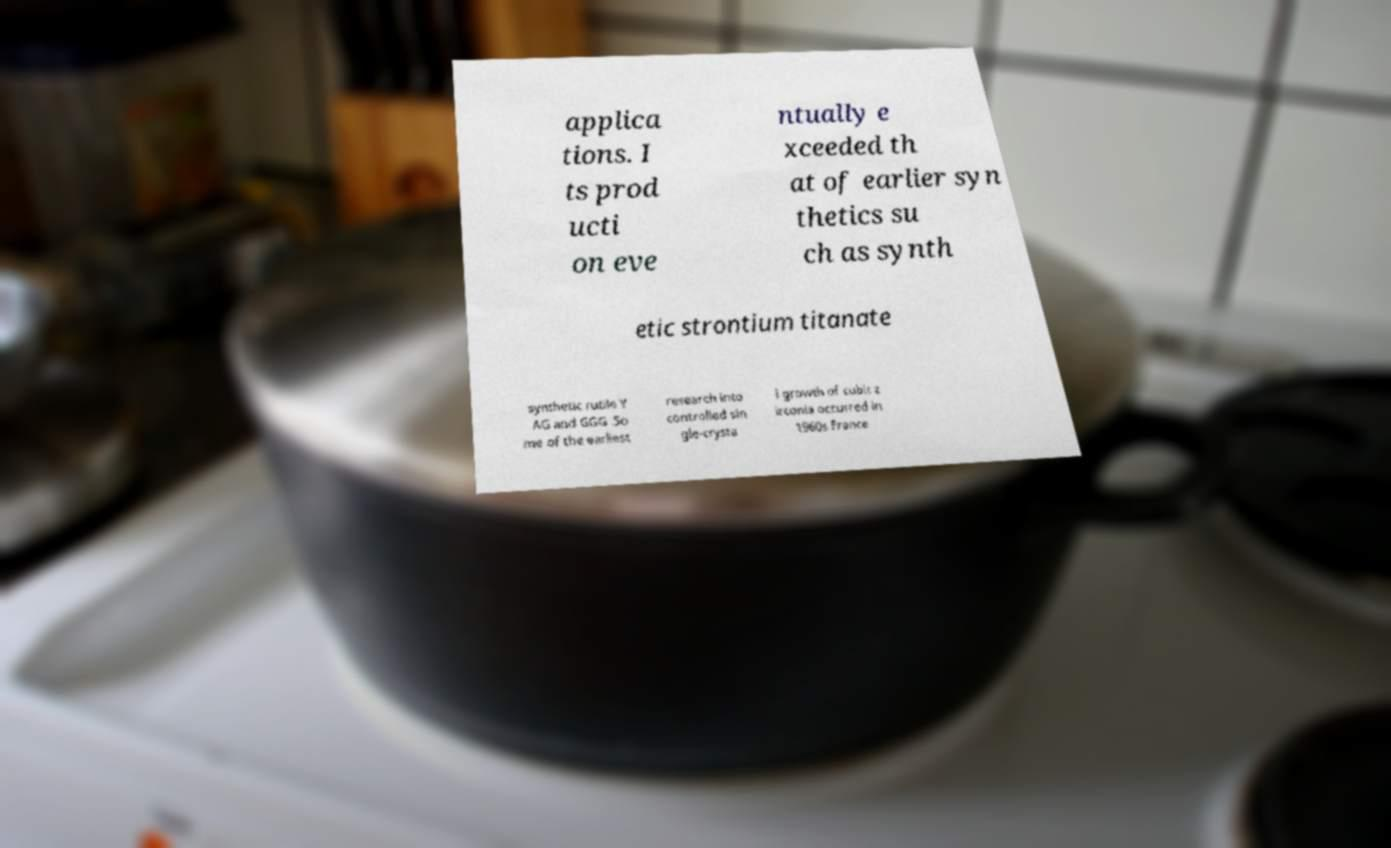What messages or text are displayed in this image? I need them in a readable, typed format. applica tions. I ts prod ucti on eve ntually e xceeded th at of earlier syn thetics su ch as synth etic strontium titanate synthetic rutile Y AG and GGG .So me of the earliest research into controlled sin gle-crysta l growth of cubic z irconia occurred in 1960s France 